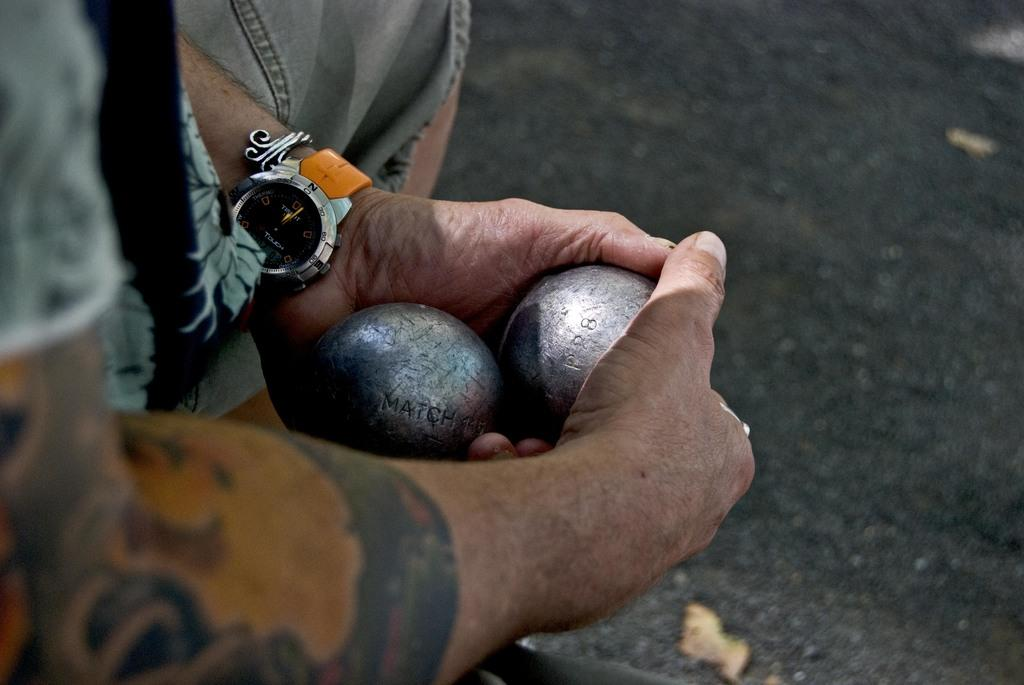<image>
Share a concise interpretation of the image provided. A man with the number 13 on a tattoo on his right are is holding two, large, metal balls. 